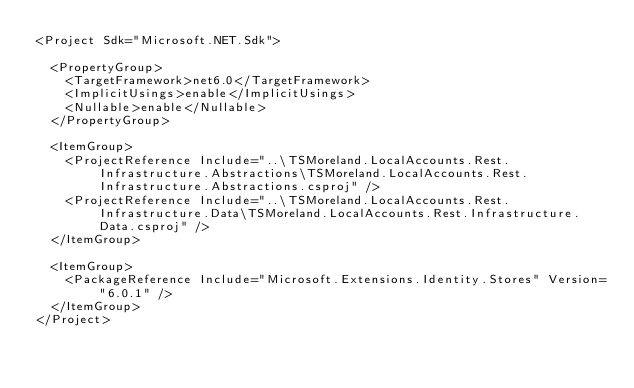<code> <loc_0><loc_0><loc_500><loc_500><_XML_><Project Sdk="Microsoft.NET.Sdk">

  <PropertyGroup>
    <TargetFramework>net6.0</TargetFramework>
    <ImplicitUsings>enable</ImplicitUsings>
    <Nullable>enable</Nullable>
  </PropertyGroup>

  <ItemGroup>
    <ProjectReference Include="..\TSMoreland.LocalAccounts.Rest.Infrastructure.Abstractions\TSMoreland.LocalAccounts.Rest.Infrastructure.Abstractions.csproj" />
    <ProjectReference Include="..\TSMoreland.LocalAccounts.Rest.Infrastructure.Data\TSMoreland.LocalAccounts.Rest.Infrastructure.Data.csproj" />
  </ItemGroup>

  <ItemGroup>
    <PackageReference Include="Microsoft.Extensions.Identity.Stores" Version="6.0.1" />
  </ItemGroup>
</Project>
</code> 